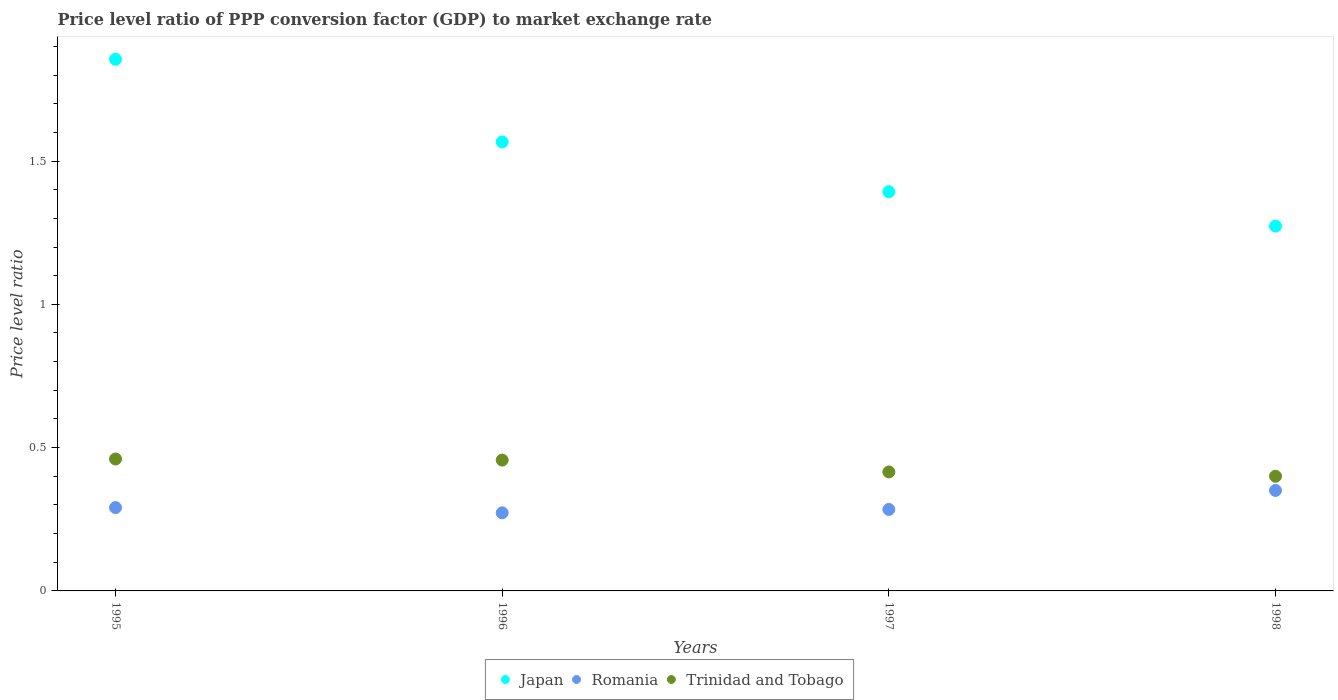What is the price level ratio in Trinidad and Tobago in 1995?
Your answer should be compact. 0.46. Across all years, what is the maximum price level ratio in Romania?
Make the answer very short. 0.35. Across all years, what is the minimum price level ratio in Japan?
Offer a very short reply. 1.27. What is the total price level ratio in Romania in the graph?
Make the answer very short. 1.2. What is the difference between the price level ratio in Japan in 1995 and that in 1996?
Provide a succinct answer. 0.29. What is the difference between the price level ratio in Trinidad and Tobago in 1997 and the price level ratio in Japan in 1995?
Give a very brief answer. -1.44. What is the average price level ratio in Romania per year?
Provide a succinct answer. 0.3. In the year 1998, what is the difference between the price level ratio in Trinidad and Tobago and price level ratio in Romania?
Your answer should be compact. 0.05. What is the ratio of the price level ratio in Japan in 1995 to that in 1997?
Your response must be concise. 1.33. Is the price level ratio in Japan in 1995 less than that in 1998?
Keep it short and to the point. No. What is the difference between the highest and the second highest price level ratio in Romania?
Your answer should be compact. 0.06. What is the difference between the highest and the lowest price level ratio in Trinidad and Tobago?
Your answer should be very brief. 0.06. Does the price level ratio in Romania monotonically increase over the years?
Provide a succinct answer. No. Are the values on the major ticks of Y-axis written in scientific E-notation?
Your response must be concise. No. Does the graph contain any zero values?
Make the answer very short. No. Where does the legend appear in the graph?
Provide a short and direct response. Bottom center. What is the title of the graph?
Keep it short and to the point. Price level ratio of PPP conversion factor (GDP) to market exchange rate. What is the label or title of the X-axis?
Your answer should be very brief. Years. What is the label or title of the Y-axis?
Provide a succinct answer. Price level ratio. What is the Price level ratio of Japan in 1995?
Provide a succinct answer. 1.86. What is the Price level ratio of Romania in 1995?
Offer a very short reply. 0.29. What is the Price level ratio in Trinidad and Tobago in 1995?
Provide a succinct answer. 0.46. What is the Price level ratio in Japan in 1996?
Offer a terse response. 1.57. What is the Price level ratio in Romania in 1996?
Offer a very short reply. 0.27. What is the Price level ratio in Trinidad and Tobago in 1996?
Give a very brief answer. 0.46. What is the Price level ratio in Japan in 1997?
Offer a terse response. 1.39. What is the Price level ratio of Romania in 1997?
Your response must be concise. 0.28. What is the Price level ratio of Trinidad and Tobago in 1997?
Your response must be concise. 0.42. What is the Price level ratio in Japan in 1998?
Ensure brevity in your answer.  1.27. What is the Price level ratio in Romania in 1998?
Make the answer very short. 0.35. What is the Price level ratio of Trinidad and Tobago in 1998?
Offer a terse response. 0.4. Across all years, what is the maximum Price level ratio in Japan?
Provide a succinct answer. 1.86. Across all years, what is the maximum Price level ratio in Romania?
Provide a succinct answer. 0.35. Across all years, what is the maximum Price level ratio of Trinidad and Tobago?
Keep it short and to the point. 0.46. Across all years, what is the minimum Price level ratio of Japan?
Provide a succinct answer. 1.27. Across all years, what is the minimum Price level ratio of Romania?
Keep it short and to the point. 0.27. Across all years, what is the minimum Price level ratio of Trinidad and Tobago?
Your answer should be very brief. 0.4. What is the total Price level ratio in Japan in the graph?
Your response must be concise. 6.09. What is the total Price level ratio of Romania in the graph?
Your answer should be compact. 1.2. What is the total Price level ratio of Trinidad and Tobago in the graph?
Offer a very short reply. 1.73. What is the difference between the Price level ratio in Japan in 1995 and that in 1996?
Provide a succinct answer. 0.29. What is the difference between the Price level ratio of Romania in 1995 and that in 1996?
Your answer should be very brief. 0.02. What is the difference between the Price level ratio in Trinidad and Tobago in 1995 and that in 1996?
Provide a succinct answer. 0. What is the difference between the Price level ratio of Japan in 1995 and that in 1997?
Provide a short and direct response. 0.46. What is the difference between the Price level ratio of Romania in 1995 and that in 1997?
Ensure brevity in your answer.  0.01. What is the difference between the Price level ratio of Trinidad and Tobago in 1995 and that in 1997?
Your answer should be very brief. 0.05. What is the difference between the Price level ratio in Japan in 1995 and that in 1998?
Give a very brief answer. 0.58. What is the difference between the Price level ratio of Romania in 1995 and that in 1998?
Your answer should be very brief. -0.06. What is the difference between the Price level ratio in Trinidad and Tobago in 1995 and that in 1998?
Your answer should be very brief. 0.06. What is the difference between the Price level ratio of Japan in 1996 and that in 1997?
Provide a succinct answer. 0.17. What is the difference between the Price level ratio of Romania in 1996 and that in 1997?
Give a very brief answer. -0.01. What is the difference between the Price level ratio in Trinidad and Tobago in 1996 and that in 1997?
Your response must be concise. 0.04. What is the difference between the Price level ratio of Japan in 1996 and that in 1998?
Offer a terse response. 0.29. What is the difference between the Price level ratio in Romania in 1996 and that in 1998?
Give a very brief answer. -0.08. What is the difference between the Price level ratio of Trinidad and Tobago in 1996 and that in 1998?
Provide a short and direct response. 0.06. What is the difference between the Price level ratio in Japan in 1997 and that in 1998?
Provide a short and direct response. 0.12. What is the difference between the Price level ratio of Romania in 1997 and that in 1998?
Provide a short and direct response. -0.07. What is the difference between the Price level ratio in Trinidad and Tobago in 1997 and that in 1998?
Your answer should be compact. 0.01. What is the difference between the Price level ratio of Japan in 1995 and the Price level ratio of Romania in 1996?
Ensure brevity in your answer.  1.58. What is the difference between the Price level ratio of Japan in 1995 and the Price level ratio of Trinidad and Tobago in 1996?
Provide a succinct answer. 1.4. What is the difference between the Price level ratio of Romania in 1995 and the Price level ratio of Trinidad and Tobago in 1996?
Your response must be concise. -0.17. What is the difference between the Price level ratio in Japan in 1995 and the Price level ratio in Romania in 1997?
Your answer should be very brief. 1.57. What is the difference between the Price level ratio of Japan in 1995 and the Price level ratio of Trinidad and Tobago in 1997?
Your answer should be very brief. 1.44. What is the difference between the Price level ratio of Romania in 1995 and the Price level ratio of Trinidad and Tobago in 1997?
Keep it short and to the point. -0.12. What is the difference between the Price level ratio in Japan in 1995 and the Price level ratio in Romania in 1998?
Keep it short and to the point. 1.5. What is the difference between the Price level ratio in Japan in 1995 and the Price level ratio in Trinidad and Tobago in 1998?
Provide a succinct answer. 1.46. What is the difference between the Price level ratio of Romania in 1995 and the Price level ratio of Trinidad and Tobago in 1998?
Provide a short and direct response. -0.11. What is the difference between the Price level ratio in Japan in 1996 and the Price level ratio in Romania in 1997?
Give a very brief answer. 1.28. What is the difference between the Price level ratio of Japan in 1996 and the Price level ratio of Trinidad and Tobago in 1997?
Ensure brevity in your answer.  1.15. What is the difference between the Price level ratio in Romania in 1996 and the Price level ratio in Trinidad and Tobago in 1997?
Your answer should be very brief. -0.14. What is the difference between the Price level ratio of Japan in 1996 and the Price level ratio of Romania in 1998?
Your answer should be compact. 1.22. What is the difference between the Price level ratio of Japan in 1996 and the Price level ratio of Trinidad and Tobago in 1998?
Provide a short and direct response. 1.17. What is the difference between the Price level ratio of Romania in 1996 and the Price level ratio of Trinidad and Tobago in 1998?
Offer a terse response. -0.13. What is the difference between the Price level ratio of Japan in 1997 and the Price level ratio of Romania in 1998?
Keep it short and to the point. 1.04. What is the difference between the Price level ratio in Japan in 1997 and the Price level ratio in Trinidad and Tobago in 1998?
Provide a succinct answer. 0.99. What is the difference between the Price level ratio of Romania in 1997 and the Price level ratio of Trinidad and Tobago in 1998?
Ensure brevity in your answer.  -0.12. What is the average Price level ratio of Japan per year?
Give a very brief answer. 1.52. What is the average Price level ratio in Romania per year?
Your answer should be compact. 0.3. What is the average Price level ratio of Trinidad and Tobago per year?
Make the answer very short. 0.43. In the year 1995, what is the difference between the Price level ratio in Japan and Price level ratio in Romania?
Offer a terse response. 1.56. In the year 1995, what is the difference between the Price level ratio of Japan and Price level ratio of Trinidad and Tobago?
Ensure brevity in your answer.  1.39. In the year 1995, what is the difference between the Price level ratio in Romania and Price level ratio in Trinidad and Tobago?
Make the answer very short. -0.17. In the year 1996, what is the difference between the Price level ratio of Japan and Price level ratio of Romania?
Your answer should be very brief. 1.29. In the year 1996, what is the difference between the Price level ratio in Japan and Price level ratio in Trinidad and Tobago?
Your answer should be compact. 1.11. In the year 1996, what is the difference between the Price level ratio of Romania and Price level ratio of Trinidad and Tobago?
Your response must be concise. -0.18. In the year 1997, what is the difference between the Price level ratio of Japan and Price level ratio of Romania?
Give a very brief answer. 1.11. In the year 1997, what is the difference between the Price level ratio in Japan and Price level ratio in Trinidad and Tobago?
Your response must be concise. 0.98. In the year 1997, what is the difference between the Price level ratio of Romania and Price level ratio of Trinidad and Tobago?
Provide a succinct answer. -0.13. In the year 1998, what is the difference between the Price level ratio in Japan and Price level ratio in Romania?
Provide a succinct answer. 0.92. In the year 1998, what is the difference between the Price level ratio of Japan and Price level ratio of Trinidad and Tobago?
Provide a succinct answer. 0.87. In the year 1998, what is the difference between the Price level ratio in Romania and Price level ratio in Trinidad and Tobago?
Your answer should be compact. -0.05. What is the ratio of the Price level ratio of Japan in 1995 to that in 1996?
Ensure brevity in your answer.  1.18. What is the ratio of the Price level ratio of Romania in 1995 to that in 1996?
Ensure brevity in your answer.  1.07. What is the ratio of the Price level ratio in Trinidad and Tobago in 1995 to that in 1996?
Ensure brevity in your answer.  1.01. What is the ratio of the Price level ratio of Japan in 1995 to that in 1997?
Your response must be concise. 1.33. What is the ratio of the Price level ratio in Romania in 1995 to that in 1997?
Ensure brevity in your answer.  1.02. What is the ratio of the Price level ratio of Trinidad and Tobago in 1995 to that in 1997?
Make the answer very short. 1.11. What is the ratio of the Price level ratio in Japan in 1995 to that in 1998?
Ensure brevity in your answer.  1.46. What is the ratio of the Price level ratio of Romania in 1995 to that in 1998?
Make the answer very short. 0.83. What is the ratio of the Price level ratio in Trinidad and Tobago in 1995 to that in 1998?
Offer a terse response. 1.15. What is the ratio of the Price level ratio in Japan in 1996 to that in 1997?
Keep it short and to the point. 1.12. What is the ratio of the Price level ratio in Romania in 1996 to that in 1997?
Give a very brief answer. 0.96. What is the ratio of the Price level ratio in Trinidad and Tobago in 1996 to that in 1997?
Your answer should be compact. 1.1. What is the ratio of the Price level ratio of Japan in 1996 to that in 1998?
Provide a short and direct response. 1.23. What is the ratio of the Price level ratio in Romania in 1996 to that in 1998?
Your answer should be compact. 0.78. What is the ratio of the Price level ratio in Trinidad and Tobago in 1996 to that in 1998?
Provide a short and direct response. 1.14. What is the ratio of the Price level ratio in Japan in 1997 to that in 1998?
Make the answer very short. 1.09. What is the ratio of the Price level ratio in Romania in 1997 to that in 1998?
Your response must be concise. 0.81. What is the ratio of the Price level ratio in Trinidad and Tobago in 1997 to that in 1998?
Ensure brevity in your answer.  1.04. What is the difference between the highest and the second highest Price level ratio of Japan?
Make the answer very short. 0.29. What is the difference between the highest and the second highest Price level ratio of Romania?
Your answer should be very brief. 0.06. What is the difference between the highest and the second highest Price level ratio of Trinidad and Tobago?
Ensure brevity in your answer.  0. What is the difference between the highest and the lowest Price level ratio in Japan?
Provide a succinct answer. 0.58. What is the difference between the highest and the lowest Price level ratio in Romania?
Ensure brevity in your answer.  0.08. What is the difference between the highest and the lowest Price level ratio of Trinidad and Tobago?
Offer a terse response. 0.06. 